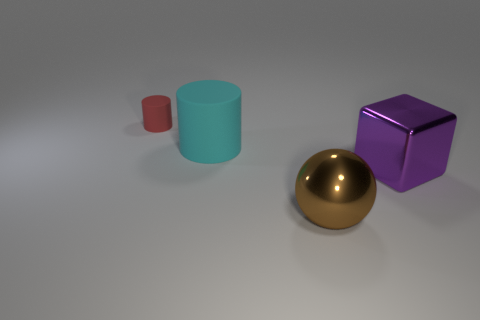Describe the lighting in the scene. Where is it coming from? The lighting in the scene appears soft and diffused, suggesting an overhead ambient light source. There are no harsh shadows, which indicates the light is not highly directional.  Is there a pattern to the arrangement of the objects, and if yes, what does it suggest? The objects are arranged with ample space between them, seemingly without a specific pattern. This layout suggests an orderly display for the purpose of comparison or showcasing each object's individual features. 